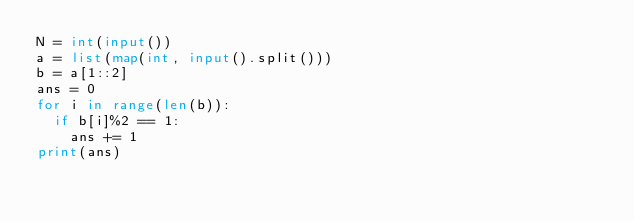<code> <loc_0><loc_0><loc_500><loc_500><_Python_>N = int(input())
a = list(map(int, input().split()))
b = a[1::2]
ans = 0
for i in range(len(b)):
  if b[i]%2 == 1:
    ans += 1
print(ans)</code> 